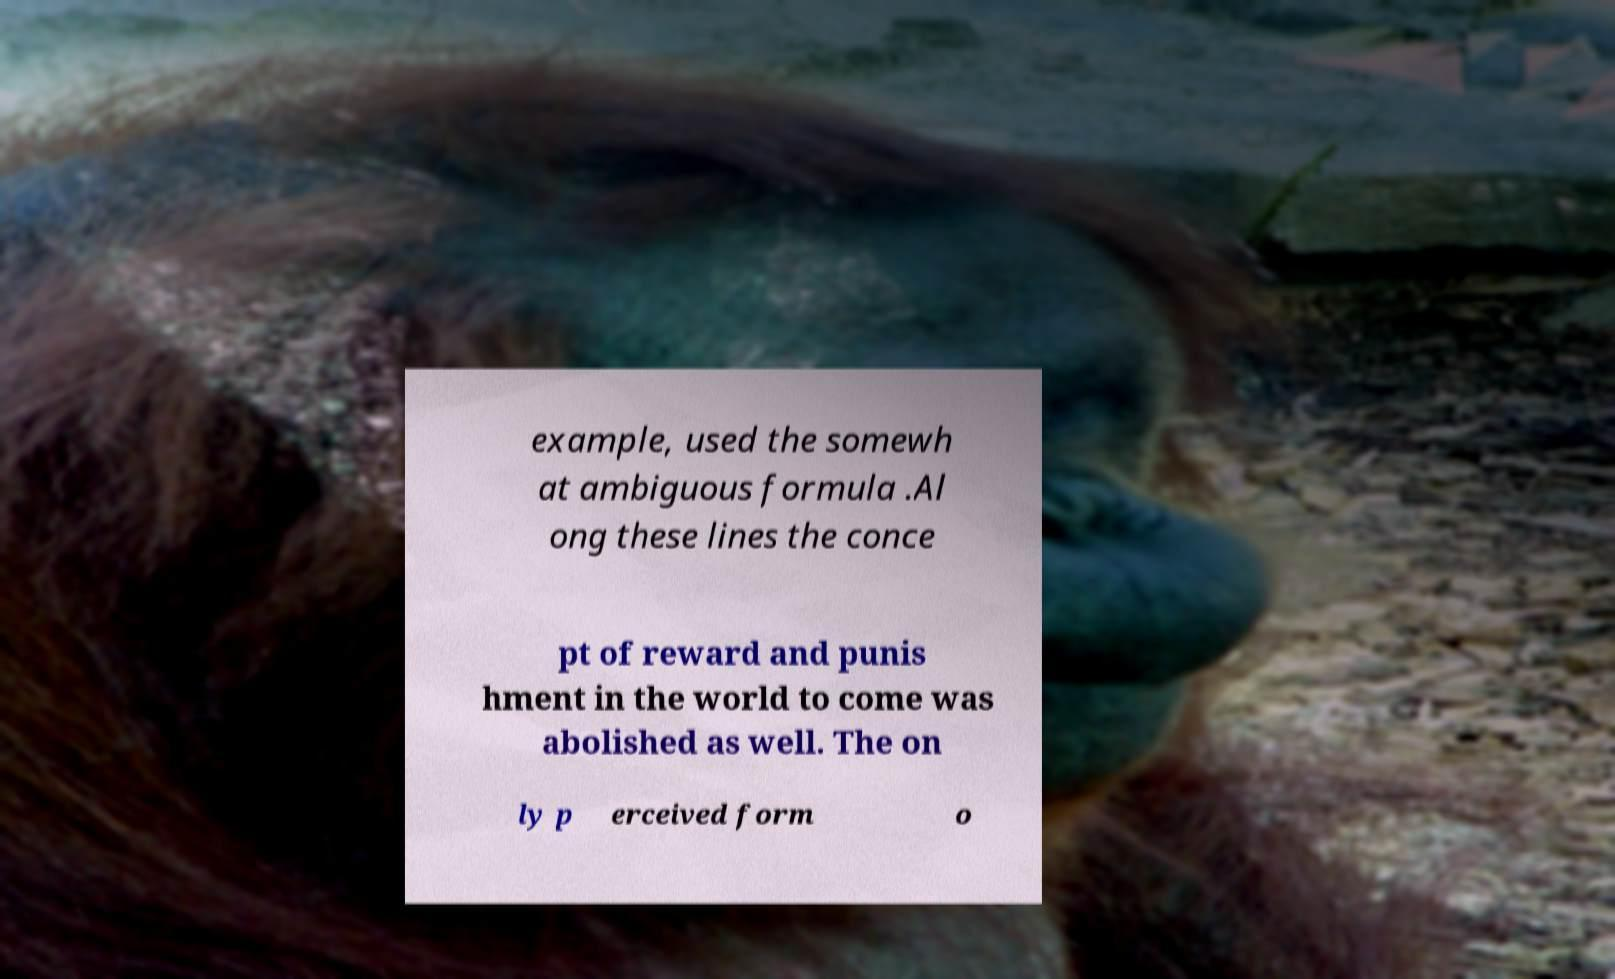Could you extract and type out the text from this image? example, used the somewh at ambiguous formula .Al ong these lines the conce pt of reward and punis hment in the world to come was abolished as well. The on ly p erceived form o 